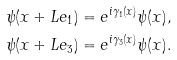Convert formula to latex. <formula><loc_0><loc_0><loc_500><loc_500>\psi ( x + L e _ { 1 } ) & = e ^ { i \gamma _ { 1 } ( x ) } \psi ( x ) , \\ \psi ( x + L e _ { 3 } ) & = e ^ { i \gamma _ { 3 } ( x ) } \psi ( x ) .</formula> 